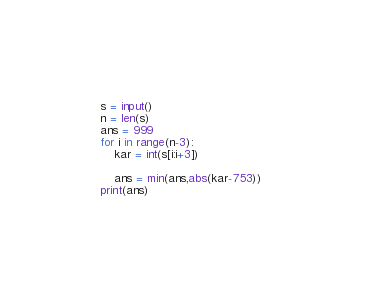<code> <loc_0><loc_0><loc_500><loc_500><_Python_>s = input()
n = len(s)
ans = 999
for i in range(n-3):
    kar = int(s[i:i+3])

    ans = min(ans,abs(kar-753)) 
print(ans)</code> 